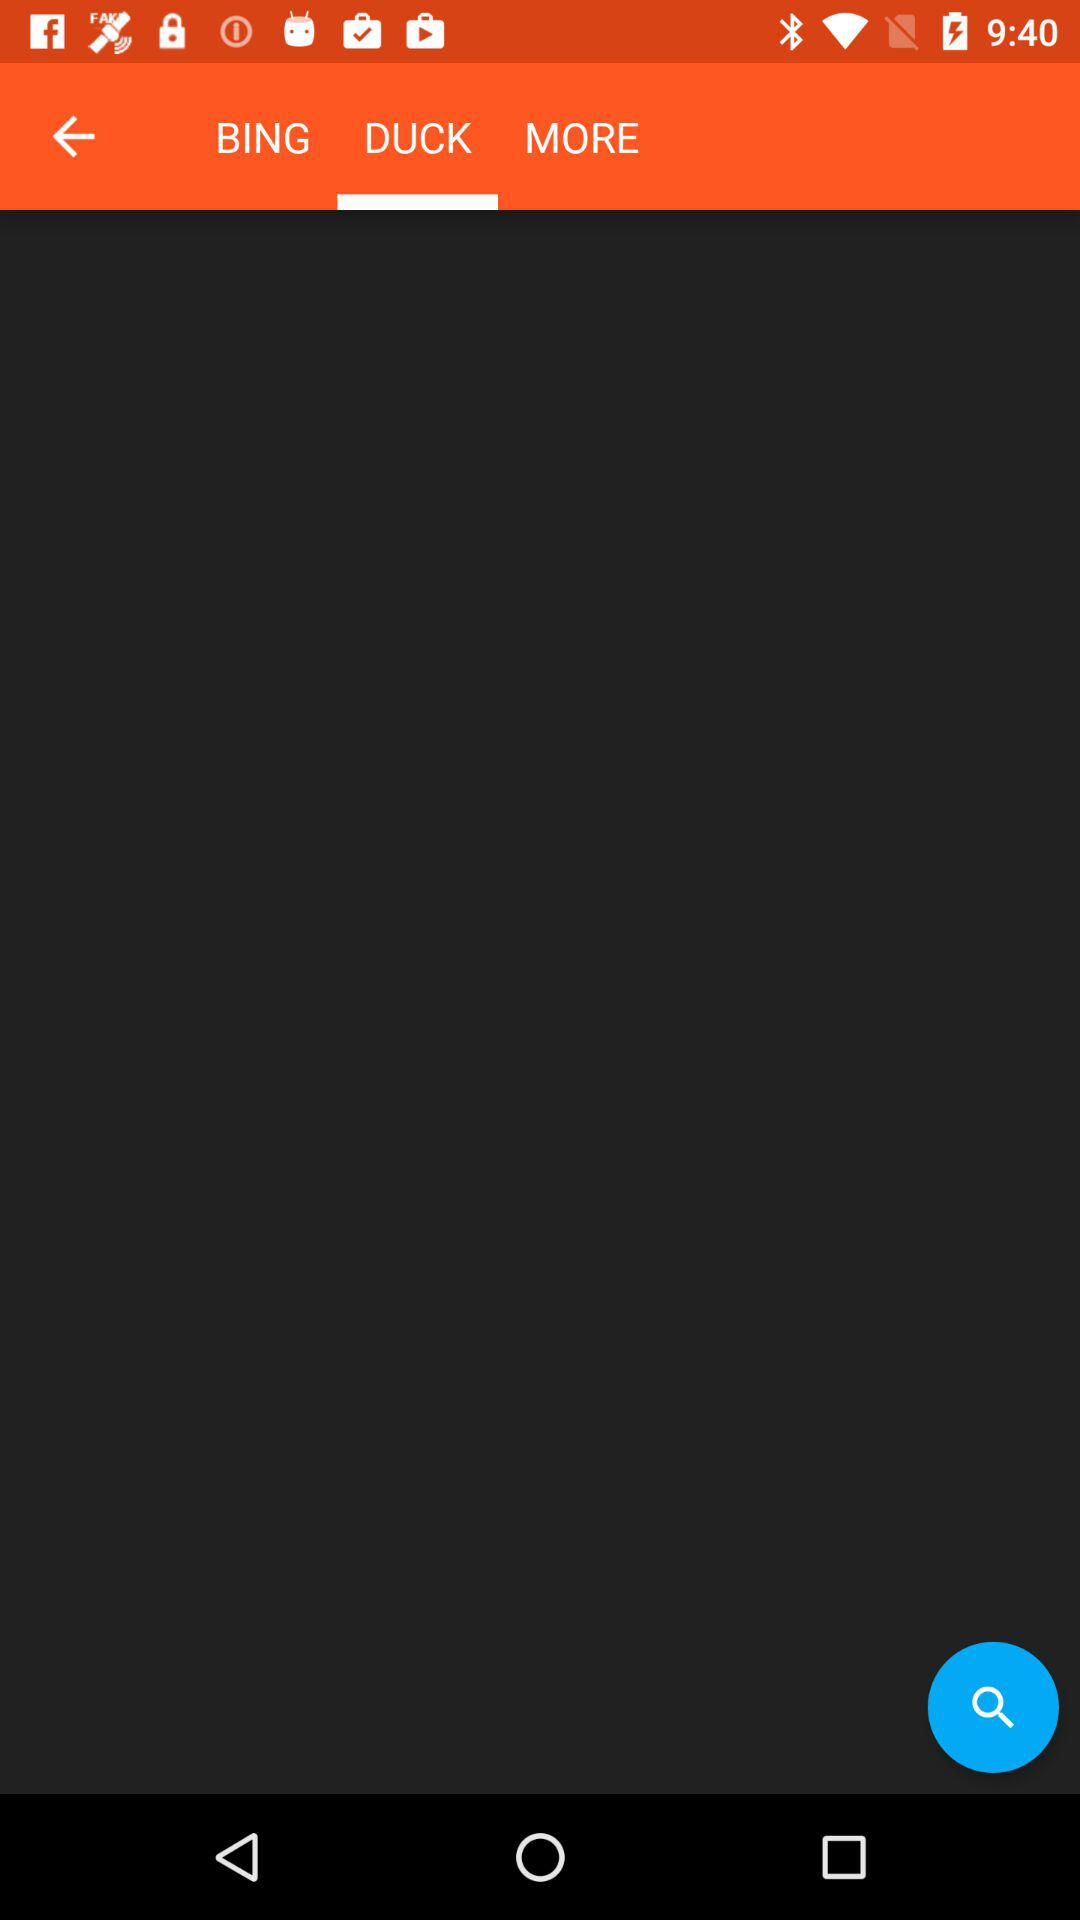Which tab is selected? The selected tab is "DUCK". 